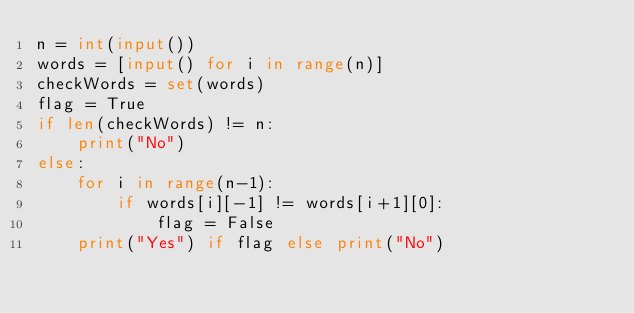Convert code to text. <code><loc_0><loc_0><loc_500><loc_500><_Python_>n = int(input())
words = [input() for i in range(n)]
checkWords = set(words)
flag = True
if len(checkWords) != n:
    print("No")
else:
    for i in range(n-1):
        if words[i][-1] != words[i+1][0]:
            flag = False
    print("Yes") if flag else print("No")</code> 